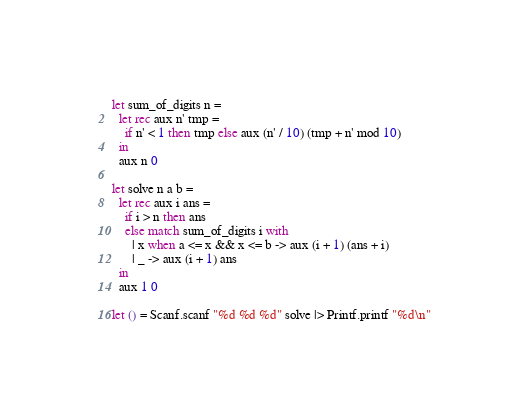Convert code to text. <code><loc_0><loc_0><loc_500><loc_500><_OCaml_>let sum_of_digits n =
  let rec aux n' tmp =
    if n' < 1 then tmp else aux (n' / 10) (tmp + n' mod 10)
  in
  aux n 0

let solve n a b =
  let rec aux i ans =
    if i > n then ans
    else match sum_of_digits i with
      | x when a <= x && x <= b -> aux (i + 1) (ans + i)
      | _ -> aux (i + 1) ans
  in
  aux 1 0

let () = Scanf.scanf "%d %d %d" solve |> Printf.printf "%d\n"</code> 